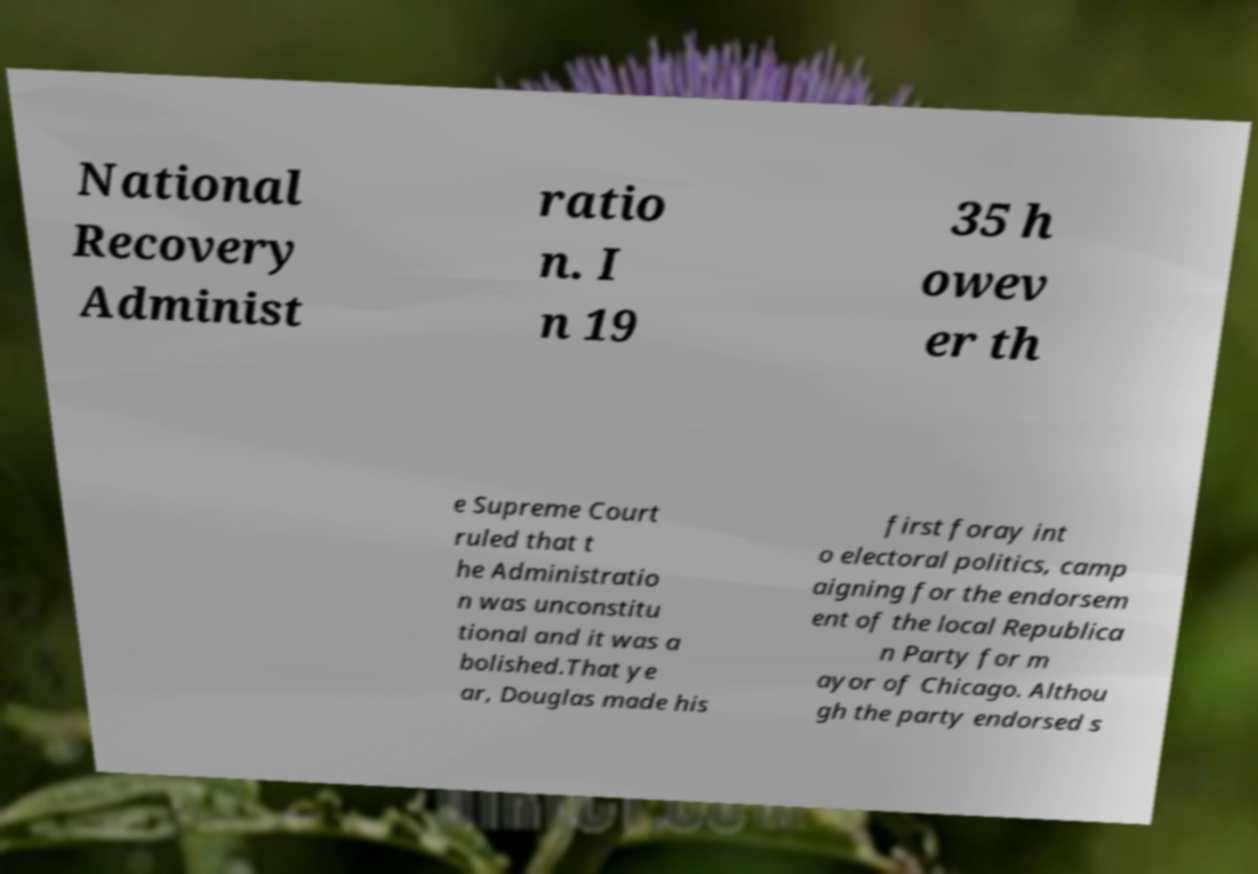Could you extract and type out the text from this image? National Recovery Administ ratio n. I n 19 35 h owev er th e Supreme Court ruled that t he Administratio n was unconstitu tional and it was a bolished.That ye ar, Douglas made his first foray int o electoral politics, camp aigning for the endorsem ent of the local Republica n Party for m ayor of Chicago. Althou gh the party endorsed s 